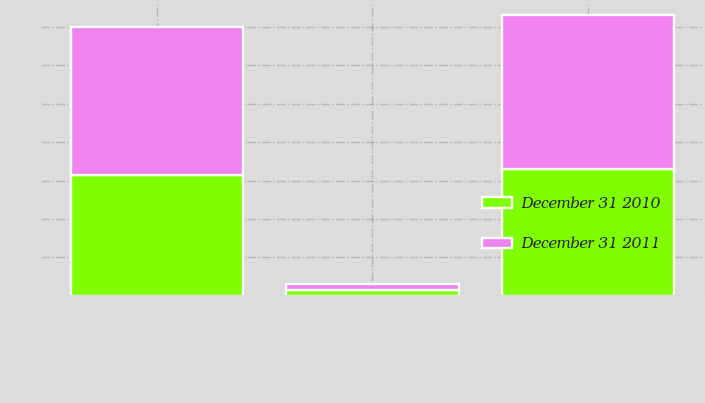<chart> <loc_0><loc_0><loc_500><loc_500><stacked_bar_chart><ecel><fcel>Equity method investments<fcel>Other<fcel>Total non-current investments<nl><fcel>December 31 2011<fcel>193.1<fcel>7.7<fcel>200.8<nl><fcel>December 31 2010<fcel>156.9<fcel>7<fcel>164.4<nl></chart> 